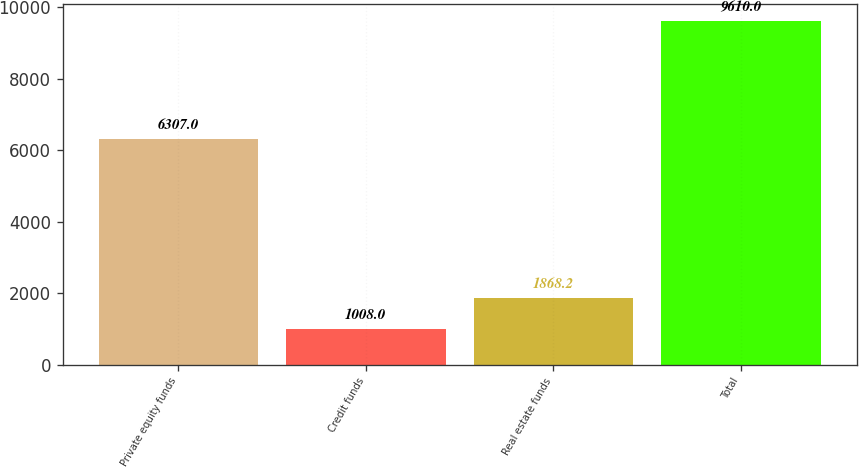<chart> <loc_0><loc_0><loc_500><loc_500><bar_chart><fcel>Private equity funds<fcel>Credit funds<fcel>Real estate funds<fcel>Total<nl><fcel>6307<fcel>1008<fcel>1868.2<fcel>9610<nl></chart> 